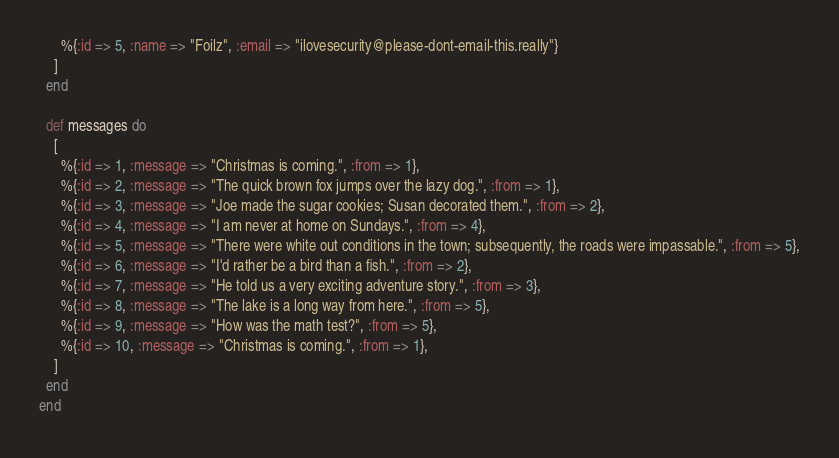<code> <loc_0><loc_0><loc_500><loc_500><_Elixir_>      %{:id => 5, :name => "Foilz", :email => "ilovesecurity@please-dont-email-this.really"}
    ]
  end

  def messages do
    [
      %{:id => 1, :message => "Christmas is coming.", :from => 1},
      %{:id => 2, :message => "The quick brown fox jumps over the lazy dog.", :from => 1},
      %{:id => 3, :message => "Joe made the sugar cookies; Susan decorated them.", :from => 2},
      %{:id => 4, :message => "I am never at home on Sundays.", :from => 4},
      %{:id => 5, :message => "There were white out conditions in the town; subsequently, the roads were impassable.", :from => 5},
      %{:id => 6, :message => "I'd rather be a bird than a fish.", :from => 2},
      %{:id => 7, :message => "He told us a very exciting adventure story.", :from => 3},
      %{:id => 8, :message => "The lake is a long way from here.", :from => 5},
      %{:id => 9, :message => "How was the math test?", :from => 5},
      %{:id => 10, :message => "Christmas is coming.", :from => 1},
    ]
  end
end
</code> 